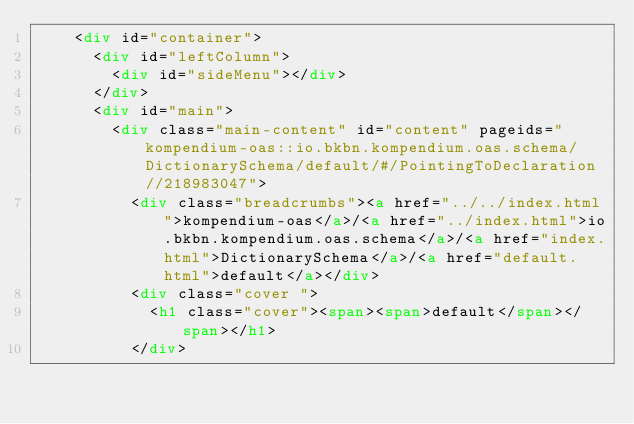<code> <loc_0><loc_0><loc_500><loc_500><_HTML_>    <div id="container">
      <div id="leftColumn">
        <div id="sideMenu"></div>
      </div>
      <div id="main">
        <div class="main-content" id="content" pageids="kompendium-oas::io.bkbn.kompendium.oas.schema/DictionarySchema/default/#/PointingToDeclaration//218983047">
          <div class="breadcrumbs"><a href="../../index.html">kompendium-oas</a>/<a href="../index.html">io.bkbn.kompendium.oas.schema</a>/<a href="index.html">DictionarySchema</a>/<a href="default.html">default</a></div>
          <div class="cover ">
            <h1 class="cover"><span><span>default</span></span></h1>
          </div></code> 